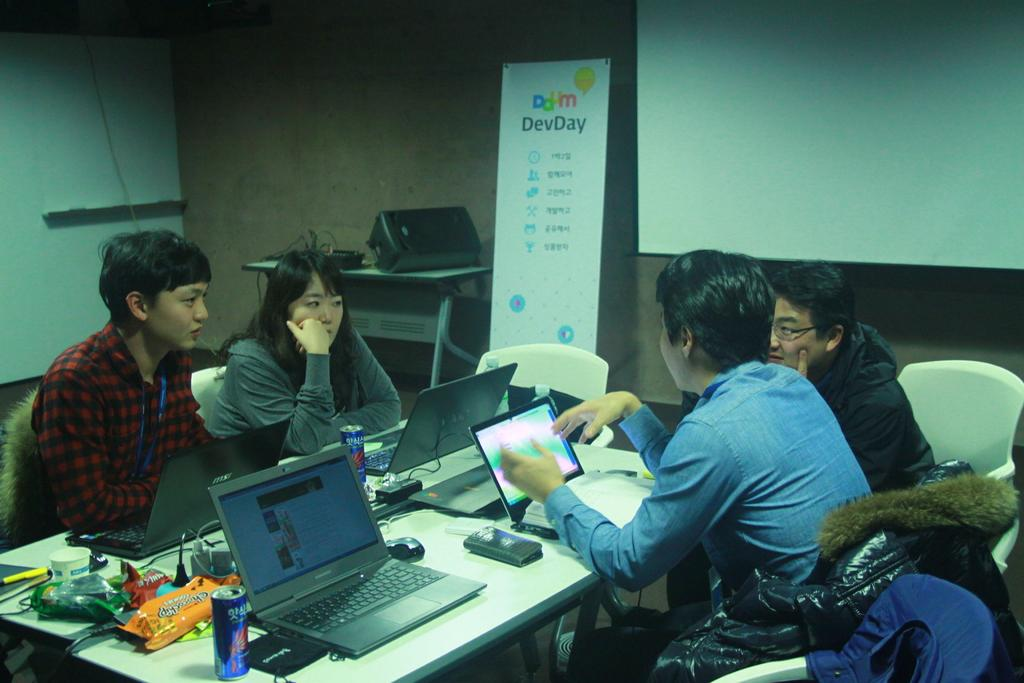<image>
Give a short and clear explanation of the subsequent image. Daum DevDay is printed on the banner against the wall. 